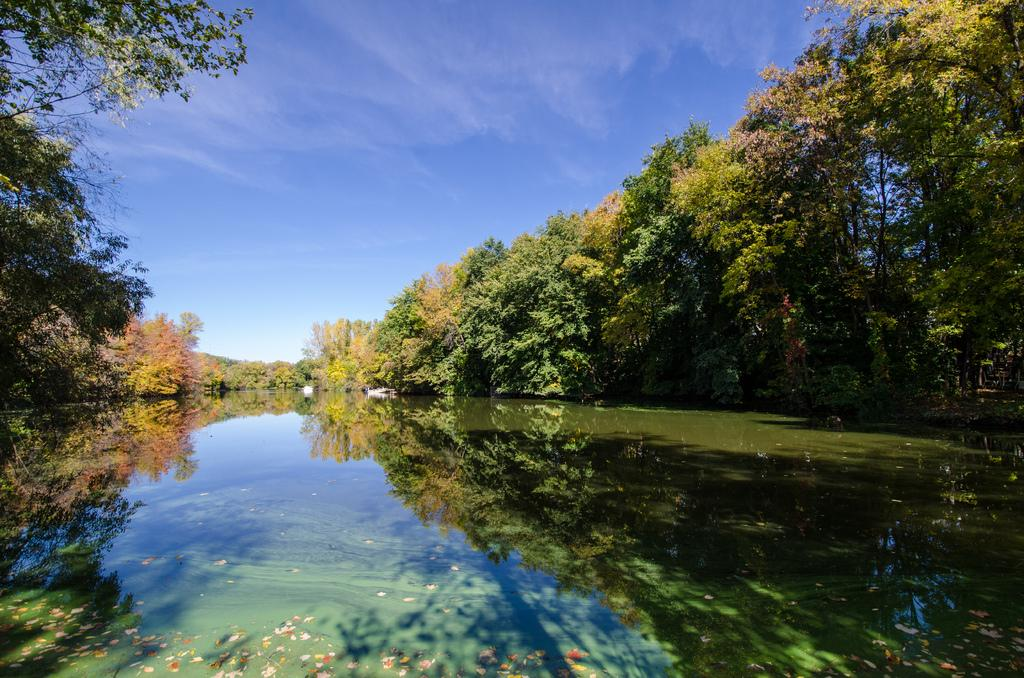Where was the image taken? The image was clicked outside the city. What can be seen in the foreground of the image? There is a water body in the foreground of the image. What is visible in the background of the image? The sky and trees are visible in the background of the image. What other natural elements can be seen in the background of the image? There are plants in the background of the image. How many dimes are floating on the water body in the image? There are no dimes visible in the image; it features a water body without any coins. What type of sock is hanging on the tree in the background of the image? There is no sock present in the image; it only features a water body, sky, trees, and plants. 